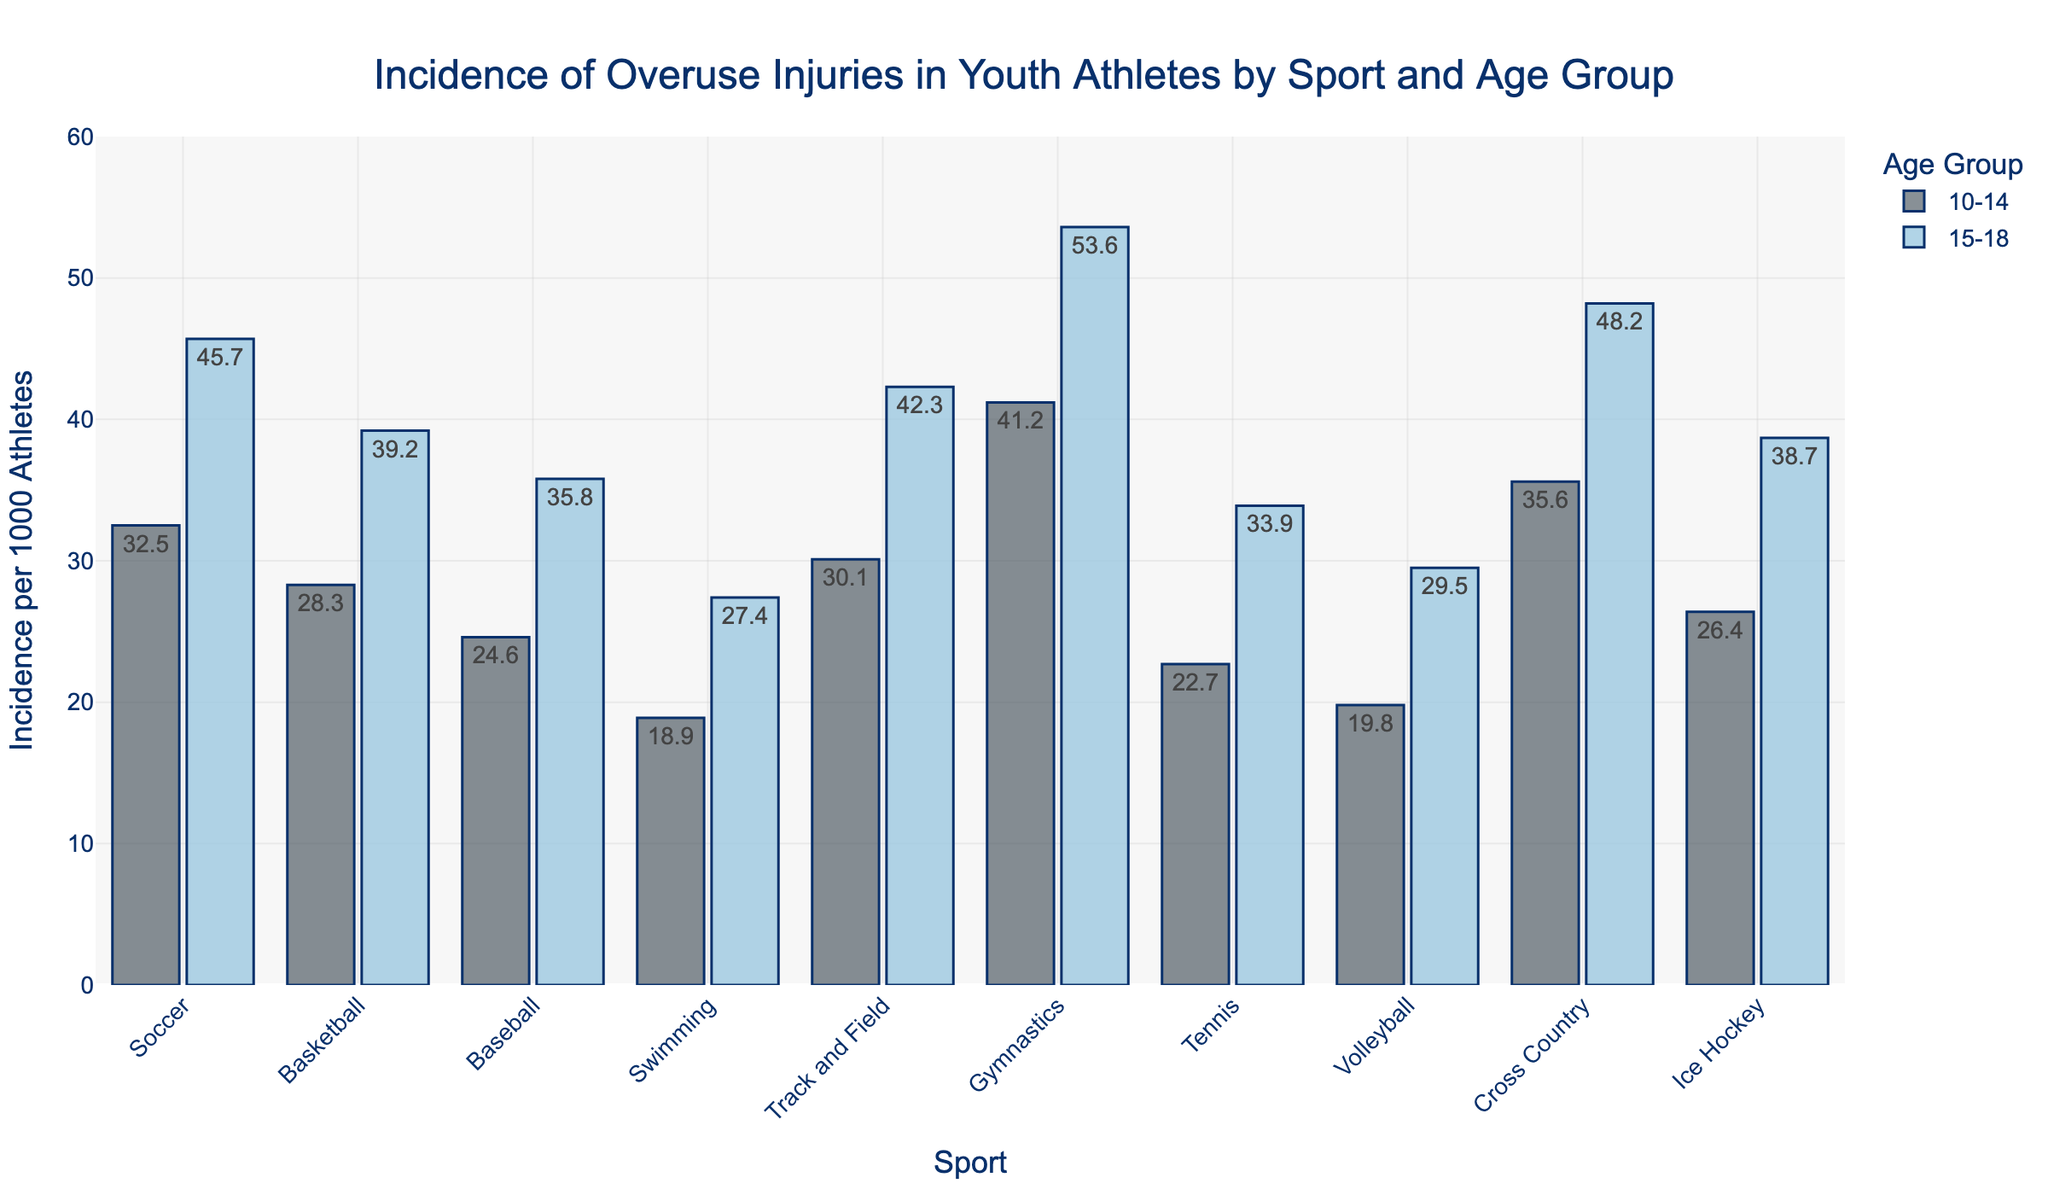Which sport and age group have the highest incidence of overuse injuries? By looking at the tallest bar in the figure, we see that Gymnastics for the 15-18 age group has the highest incidence of overuse injuries, with an incidence rate shown at the top of the bar.
Answer: Gymnastics, 15-18 How does the incidence of overuse injuries in Soccer compare between the 10-14 and 15-18 age groups? Compare the height of the bars for Soccer. The 15-18 age group has a higher incidence than the 10-14 age group, with 45.7 versus 32.5 per 1000 athletes.
Answer: 15-18 age group has a higher incidence What is the difference in overuse injury incidence between Track and Field for the two age groups? Subtract the incidence for the 10-14 age group (30.1) from the incidence for the 15-18 age group (42.3).
Answer: 12.2 Which sports have a lower incidence of overuse injuries in the 15-18 age group compared to the incidence in the 10-14 age group? Review the bars for each sport and compare the incidences for the two age groups. None of the sports have a lower incidence in the 15-18 age group compared to the 10-14 age group.
Answer: None What is the total incidence of overuse injuries for Gymnastics across both age groups? Add the incidence rates for the 10-14 age group (41.2) and the 15-18 age group (53.6).
Answer: 94.8 Which sport has the smallest increase in incidence of overuse injuries from the 10-14 age group to the 15-18 age group? Calculate the difference between the incidence rates for both age groups for each sport and identify the smallest difference. Tennis has the smallest increase, from 22.7 to 33.9, which is an increase of 11.2.
Answer: Tennis What is the average incidence of overuse injuries for Ice Hockey across both age groups? Add the incidence rates for the 10-14 age group (26.4) and the 15-18 age group (38.7), then divide by 2.
Answer: 32.55 Among all sports, which has the highest incidence of overuse injuries for the 10-14 age group? Look for the tallest bar among the bars representing the 10-14 age group. Gymnastics has the highest incidence with 41.2.
Answer: Gymnastics How does the incidence of overuse injuries in Swimming for the 15-18 age group compare to Volleyball for the same age group? Compare the heights of the bars. The 15-18 age group in Swimming has an incidence rate of 27.4, while Volleyball has an incidence rate of 29.5.
Answer: Volleyball is higher 